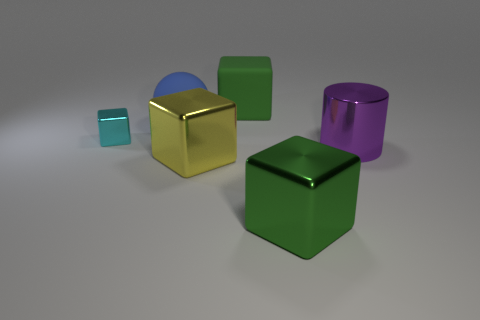There is a large green object that is the same material as the big ball; what is its shape?
Offer a terse response. Cube. How many other things are the same shape as the tiny metallic thing?
Offer a very short reply. 3. What is the shape of the big rubber thing that is to the right of the yellow shiny object?
Provide a succinct answer. Cube. The sphere is what color?
Provide a short and direct response. Blue. What number of other things are the same size as the cyan thing?
Provide a succinct answer. 0. What material is the green block right of the big green thing that is behind the large purple cylinder?
Ensure brevity in your answer.  Metal. There is a rubber ball; is it the same size as the shiny cube in front of the large yellow shiny cube?
Your answer should be compact. Yes. Are there any matte objects of the same color as the ball?
Offer a terse response. No. How many tiny things are green shiny cubes or yellow cubes?
Offer a very short reply. 0. How many brown cubes are there?
Your answer should be compact. 0. 